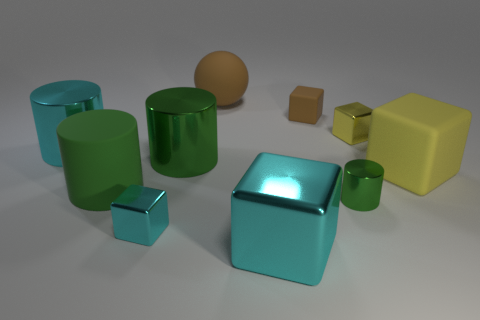Imagine these objects are part of a set, what could be their purpose? If these objects are part of a set, they could serve as educational tools for a variety of subjects. Their different shapes and sizes could be useful for teaching geometry and spatial concepts. They might also be a part of a designer's toolset for physical mock-ups to visualize how different shapes can coexist in a space or be used to create abstract art installations. 